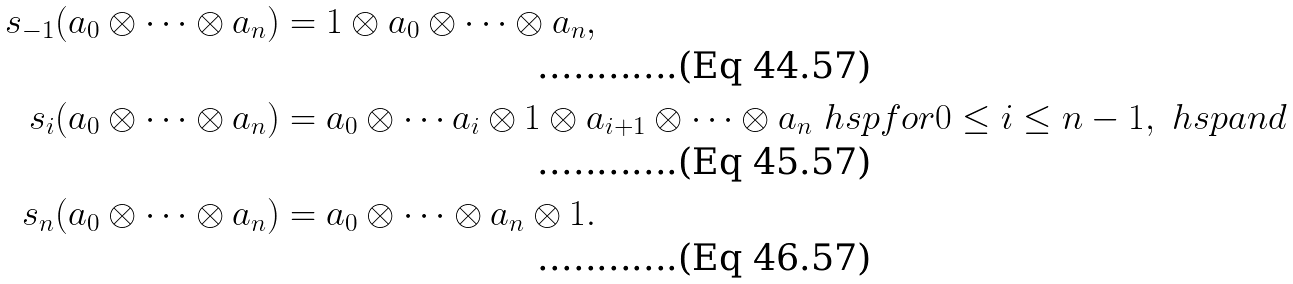<formula> <loc_0><loc_0><loc_500><loc_500>s _ { - 1 } ( a _ { 0 } \otimes \cdots \otimes a _ { n } ) & = 1 \otimes a _ { 0 } \otimes \cdots \otimes a _ { n } , \\ s _ { i } ( a _ { 0 } \otimes \cdots \otimes a _ { n } ) & = a _ { 0 } \otimes \cdots a _ { i } \otimes 1 \otimes a _ { i + 1 } \otimes \cdots \otimes a _ { n } \ h s p { f o r } 0 \leq i \leq n - 1 , \ h s p { a n d } \\ s _ { n } ( a _ { 0 } \otimes \cdots \otimes a _ { n } ) & = a _ { 0 } \otimes \cdots \otimes a _ { n } \otimes 1 .</formula> 